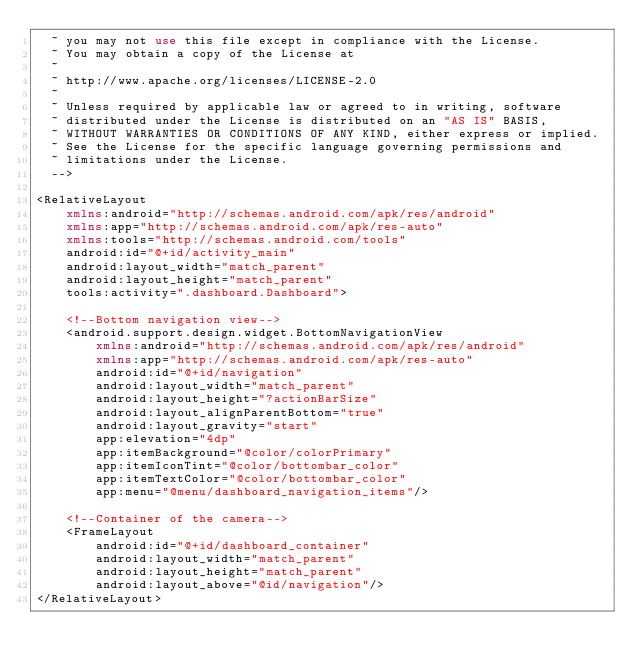Convert code to text. <code><loc_0><loc_0><loc_500><loc_500><_XML_>  ~ you may not use this file except in compliance with the License.
  ~ You may obtain a copy of the License at
  ~
  ~ http://www.apache.org/licenses/LICENSE-2.0
  ~
  ~ Unless required by applicable law or agreed to in writing, software
  ~ distributed under the License is distributed on an "AS IS" BASIS,
  ~ WITHOUT WARRANTIES OR CONDITIONS OF ANY KIND, either express or implied.
  ~ See the License for the specific language governing permissions and
  ~ limitations under the License.
  -->

<RelativeLayout
    xmlns:android="http://schemas.android.com/apk/res/android"
    xmlns:app="http://schemas.android.com/apk/res-auto"
    xmlns:tools="http://schemas.android.com/tools"
    android:id="@+id/activity_main"
    android:layout_width="match_parent"
    android:layout_height="match_parent"
    tools:activity=".dashboard.Dashboard">

    <!--Bottom navigation view-->
    <android.support.design.widget.BottomNavigationView
        xmlns:android="http://schemas.android.com/apk/res/android"
        xmlns:app="http://schemas.android.com/apk/res-auto"
        android:id="@+id/navigation"
        android:layout_width="match_parent"
        android:layout_height="?actionBarSize"
        android:layout_alignParentBottom="true"
        android:layout_gravity="start"
        app:elevation="4dp"
        app:itemBackground="@color/colorPrimary"
        app:itemIconTint="@color/bottombar_color"
        app:itemTextColor="@color/bottombar_color"
        app:menu="@menu/dashboard_navigation_items"/>

    <!--Container of the camera-->
    <FrameLayout
        android:id="@+id/dashboard_container"
        android:layout_width="match_parent"
        android:layout_height="match_parent"
        android:layout_above="@id/navigation"/>
</RelativeLayout>
</code> 